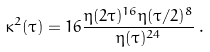<formula> <loc_0><loc_0><loc_500><loc_500>\kappa ^ { 2 } ( \tau ) = 1 6 \frac { \eta ( 2 \tau ) ^ { 1 6 } \eta ( \tau / 2 ) ^ { 8 } } { \eta ( \tau ) ^ { 2 4 } } \, .</formula> 